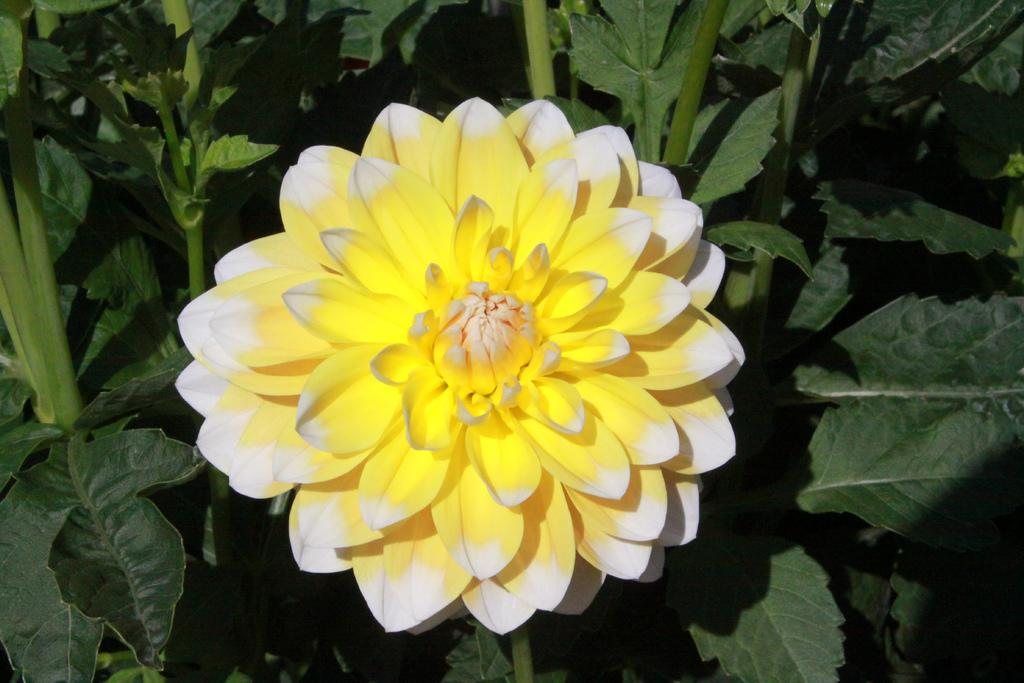What type of flower is in the image? There is a white and yellow color flower in the image. What can be seen behind the flower? Leaves and stems are visible behind the flower. What is the behavior of the flower in the image? The flower is not exhibiting any behavior, as it is a static image. 